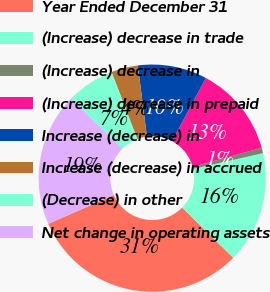<chart> <loc_0><loc_0><loc_500><loc_500><pie_chart><fcel>Year Ended December 31<fcel>(Increase) decrease in trade<fcel>(Increase) decrease in<fcel>(Increase) decrease in prepaid<fcel>Increase (decrease) in<fcel>Increase (decrease) in accrued<fcel>(Decrease) in other<fcel>Net change in operating assets<nl><fcel>31.04%<fcel>15.9%<fcel>0.77%<fcel>12.88%<fcel>9.85%<fcel>3.8%<fcel>6.83%<fcel>18.93%<nl></chart> 